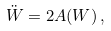Convert formula to latex. <formula><loc_0><loc_0><loc_500><loc_500>\ddot { W } = 2 A ( W ) \, ,</formula> 